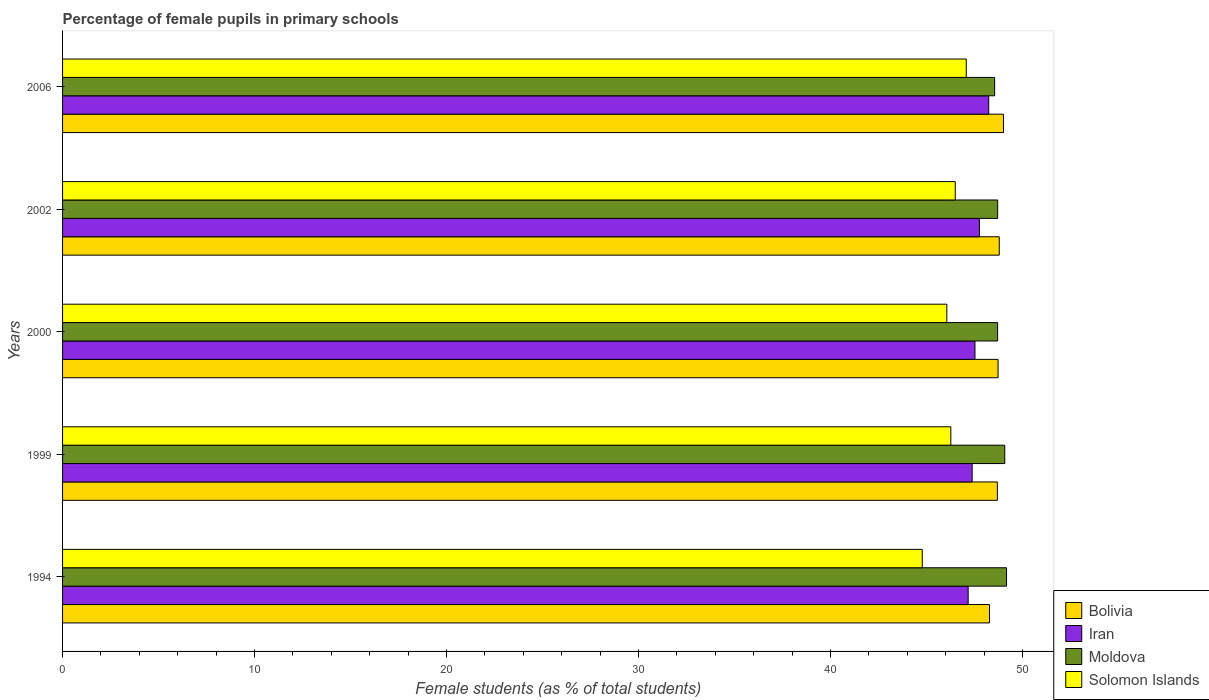How many different coloured bars are there?
Offer a terse response. 4. How many groups of bars are there?
Your answer should be very brief. 5. Are the number of bars per tick equal to the number of legend labels?
Your answer should be compact. Yes. Are the number of bars on each tick of the Y-axis equal?
Offer a very short reply. Yes. In how many cases, is the number of bars for a given year not equal to the number of legend labels?
Make the answer very short. 0. What is the percentage of female pupils in primary schools in Iran in 2002?
Keep it short and to the point. 47.76. Across all years, what is the maximum percentage of female pupils in primary schools in Iran?
Provide a short and direct response. 48.24. Across all years, what is the minimum percentage of female pupils in primary schools in Solomon Islands?
Your response must be concise. 44.78. In which year was the percentage of female pupils in primary schools in Solomon Islands minimum?
Provide a short and direct response. 1994. What is the total percentage of female pupils in primary schools in Bolivia in the graph?
Offer a terse response. 243.51. What is the difference between the percentage of female pupils in primary schools in Moldova in 1999 and that in 2006?
Provide a succinct answer. 0.53. What is the difference between the percentage of female pupils in primary schools in Moldova in 2006 and the percentage of female pupils in primary schools in Solomon Islands in 2000?
Your answer should be compact. 2.49. What is the average percentage of female pupils in primary schools in Iran per year?
Provide a short and direct response. 47.62. In the year 2000, what is the difference between the percentage of female pupils in primary schools in Iran and percentage of female pupils in primary schools in Moldova?
Your answer should be compact. -1.18. What is the ratio of the percentage of female pupils in primary schools in Bolivia in 1999 to that in 2000?
Provide a short and direct response. 1. Is the percentage of female pupils in primary schools in Iran in 1994 less than that in 2002?
Provide a short and direct response. Yes. What is the difference between the highest and the second highest percentage of female pupils in primary schools in Bolivia?
Give a very brief answer. 0.22. What is the difference between the highest and the lowest percentage of female pupils in primary schools in Bolivia?
Keep it short and to the point. 0.73. Is it the case that in every year, the sum of the percentage of female pupils in primary schools in Solomon Islands and percentage of female pupils in primary schools in Bolivia is greater than the sum of percentage of female pupils in primary schools in Moldova and percentage of female pupils in primary schools in Iran?
Provide a short and direct response. No. What does the 2nd bar from the top in 1994 represents?
Make the answer very short. Moldova. What does the 4th bar from the bottom in 2006 represents?
Keep it short and to the point. Solomon Islands. Is it the case that in every year, the sum of the percentage of female pupils in primary schools in Iran and percentage of female pupils in primary schools in Solomon Islands is greater than the percentage of female pupils in primary schools in Moldova?
Your response must be concise. Yes. How many bars are there?
Your answer should be compact. 20. How many years are there in the graph?
Offer a terse response. 5. Does the graph contain any zero values?
Make the answer very short. No. How many legend labels are there?
Provide a succinct answer. 4. How are the legend labels stacked?
Your answer should be very brief. Vertical. What is the title of the graph?
Make the answer very short. Percentage of female pupils in primary schools. What is the label or title of the X-axis?
Offer a terse response. Female students (as % of total students). What is the Female students (as % of total students) of Bolivia in 1994?
Give a very brief answer. 48.28. What is the Female students (as % of total students) in Iran in 1994?
Make the answer very short. 47.17. What is the Female students (as % of total students) of Moldova in 1994?
Provide a short and direct response. 49.17. What is the Female students (as % of total students) of Solomon Islands in 1994?
Your answer should be very brief. 44.78. What is the Female students (as % of total students) of Bolivia in 1999?
Offer a terse response. 48.69. What is the Female students (as % of total students) of Iran in 1999?
Your answer should be very brief. 47.38. What is the Female students (as % of total students) of Moldova in 1999?
Offer a terse response. 49.08. What is the Female students (as % of total students) of Solomon Islands in 1999?
Your answer should be very brief. 46.27. What is the Female students (as % of total students) of Bolivia in 2000?
Your answer should be compact. 48.73. What is the Female students (as % of total students) in Iran in 2000?
Ensure brevity in your answer.  47.53. What is the Female students (as % of total students) in Moldova in 2000?
Give a very brief answer. 48.71. What is the Female students (as % of total students) in Solomon Islands in 2000?
Your response must be concise. 46.06. What is the Female students (as % of total students) of Bolivia in 2002?
Ensure brevity in your answer.  48.79. What is the Female students (as % of total students) of Iran in 2002?
Your response must be concise. 47.76. What is the Female students (as % of total students) in Moldova in 2002?
Provide a short and direct response. 48.71. What is the Female students (as % of total students) in Solomon Islands in 2002?
Give a very brief answer. 46.5. What is the Female students (as % of total students) in Bolivia in 2006?
Provide a short and direct response. 49.01. What is the Female students (as % of total students) in Iran in 2006?
Make the answer very short. 48.24. What is the Female students (as % of total students) of Moldova in 2006?
Your answer should be compact. 48.55. What is the Female students (as % of total students) of Solomon Islands in 2006?
Provide a short and direct response. 47.07. Across all years, what is the maximum Female students (as % of total students) of Bolivia?
Make the answer very short. 49.01. Across all years, what is the maximum Female students (as % of total students) of Iran?
Provide a succinct answer. 48.24. Across all years, what is the maximum Female students (as % of total students) in Moldova?
Offer a terse response. 49.17. Across all years, what is the maximum Female students (as % of total students) in Solomon Islands?
Ensure brevity in your answer.  47.07. Across all years, what is the minimum Female students (as % of total students) in Bolivia?
Make the answer very short. 48.28. Across all years, what is the minimum Female students (as % of total students) in Iran?
Make the answer very short. 47.17. Across all years, what is the minimum Female students (as % of total students) in Moldova?
Offer a terse response. 48.55. Across all years, what is the minimum Female students (as % of total students) in Solomon Islands?
Your answer should be very brief. 44.78. What is the total Female students (as % of total students) of Bolivia in the graph?
Your answer should be very brief. 243.51. What is the total Female students (as % of total students) of Iran in the graph?
Provide a short and direct response. 238.08. What is the total Female students (as % of total students) of Moldova in the graph?
Ensure brevity in your answer.  244.22. What is the total Female students (as % of total students) of Solomon Islands in the graph?
Provide a short and direct response. 230.68. What is the difference between the Female students (as % of total students) of Bolivia in 1994 and that in 1999?
Ensure brevity in your answer.  -0.41. What is the difference between the Female students (as % of total students) of Iran in 1994 and that in 1999?
Give a very brief answer. -0.21. What is the difference between the Female students (as % of total students) in Moldova in 1994 and that in 1999?
Give a very brief answer. 0.09. What is the difference between the Female students (as % of total students) of Solomon Islands in 1994 and that in 1999?
Keep it short and to the point. -1.49. What is the difference between the Female students (as % of total students) of Bolivia in 1994 and that in 2000?
Offer a very short reply. -0.45. What is the difference between the Female students (as % of total students) of Iran in 1994 and that in 2000?
Make the answer very short. -0.36. What is the difference between the Female students (as % of total students) of Moldova in 1994 and that in 2000?
Give a very brief answer. 0.46. What is the difference between the Female students (as % of total students) in Solomon Islands in 1994 and that in 2000?
Provide a short and direct response. -1.28. What is the difference between the Female students (as % of total students) in Bolivia in 1994 and that in 2002?
Keep it short and to the point. -0.51. What is the difference between the Female students (as % of total students) in Iran in 1994 and that in 2002?
Your answer should be very brief. -0.59. What is the difference between the Female students (as % of total students) in Moldova in 1994 and that in 2002?
Give a very brief answer. 0.46. What is the difference between the Female students (as % of total students) in Solomon Islands in 1994 and that in 2002?
Make the answer very short. -1.72. What is the difference between the Female students (as % of total students) of Bolivia in 1994 and that in 2006?
Provide a short and direct response. -0.73. What is the difference between the Female students (as % of total students) in Iran in 1994 and that in 2006?
Your answer should be compact. -1.07. What is the difference between the Female students (as % of total students) of Moldova in 1994 and that in 2006?
Ensure brevity in your answer.  0.62. What is the difference between the Female students (as % of total students) in Solomon Islands in 1994 and that in 2006?
Provide a short and direct response. -2.29. What is the difference between the Female students (as % of total students) in Bolivia in 1999 and that in 2000?
Your answer should be compact. -0.04. What is the difference between the Female students (as % of total students) in Iran in 1999 and that in 2000?
Provide a succinct answer. -0.15. What is the difference between the Female students (as % of total students) in Moldova in 1999 and that in 2000?
Your answer should be compact. 0.37. What is the difference between the Female students (as % of total students) of Solomon Islands in 1999 and that in 2000?
Provide a short and direct response. 0.21. What is the difference between the Female students (as % of total students) in Bolivia in 1999 and that in 2002?
Keep it short and to the point. -0.1. What is the difference between the Female students (as % of total students) of Iran in 1999 and that in 2002?
Ensure brevity in your answer.  -0.38. What is the difference between the Female students (as % of total students) in Moldova in 1999 and that in 2002?
Your answer should be very brief. 0.37. What is the difference between the Female students (as % of total students) in Solomon Islands in 1999 and that in 2002?
Keep it short and to the point. -0.23. What is the difference between the Female students (as % of total students) of Bolivia in 1999 and that in 2006?
Your answer should be very brief. -0.32. What is the difference between the Female students (as % of total students) of Iran in 1999 and that in 2006?
Your answer should be very brief. -0.86. What is the difference between the Female students (as % of total students) in Moldova in 1999 and that in 2006?
Your response must be concise. 0.53. What is the difference between the Female students (as % of total students) in Solomon Islands in 1999 and that in 2006?
Provide a short and direct response. -0.8. What is the difference between the Female students (as % of total students) in Bolivia in 2000 and that in 2002?
Keep it short and to the point. -0.06. What is the difference between the Female students (as % of total students) of Iran in 2000 and that in 2002?
Provide a succinct answer. -0.23. What is the difference between the Female students (as % of total students) in Moldova in 2000 and that in 2002?
Give a very brief answer. -0. What is the difference between the Female students (as % of total students) in Solomon Islands in 2000 and that in 2002?
Your answer should be compact. -0.44. What is the difference between the Female students (as % of total students) of Bolivia in 2000 and that in 2006?
Provide a short and direct response. -0.28. What is the difference between the Female students (as % of total students) in Iran in 2000 and that in 2006?
Give a very brief answer. -0.72. What is the difference between the Female students (as % of total students) of Moldova in 2000 and that in 2006?
Offer a very short reply. 0.15. What is the difference between the Female students (as % of total students) of Solomon Islands in 2000 and that in 2006?
Keep it short and to the point. -1.01. What is the difference between the Female students (as % of total students) in Bolivia in 2002 and that in 2006?
Provide a succinct answer. -0.22. What is the difference between the Female students (as % of total students) of Iran in 2002 and that in 2006?
Give a very brief answer. -0.48. What is the difference between the Female students (as % of total students) in Moldova in 2002 and that in 2006?
Make the answer very short. 0.16. What is the difference between the Female students (as % of total students) of Solomon Islands in 2002 and that in 2006?
Offer a terse response. -0.57. What is the difference between the Female students (as % of total students) in Bolivia in 1994 and the Female students (as % of total students) in Iran in 1999?
Provide a short and direct response. 0.9. What is the difference between the Female students (as % of total students) of Bolivia in 1994 and the Female students (as % of total students) of Moldova in 1999?
Offer a terse response. -0.79. What is the difference between the Female students (as % of total students) of Bolivia in 1994 and the Female students (as % of total students) of Solomon Islands in 1999?
Offer a terse response. 2.01. What is the difference between the Female students (as % of total students) in Iran in 1994 and the Female students (as % of total students) in Moldova in 1999?
Your response must be concise. -1.91. What is the difference between the Female students (as % of total students) of Iran in 1994 and the Female students (as % of total students) of Solomon Islands in 1999?
Offer a very short reply. 0.9. What is the difference between the Female students (as % of total students) in Moldova in 1994 and the Female students (as % of total students) in Solomon Islands in 1999?
Keep it short and to the point. 2.9. What is the difference between the Female students (as % of total students) in Bolivia in 1994 and the Female students (as % of total students) in Iran in 2000?
Ensure brevity in your answer.  0.76. What is the difference between the Female students (as % of total students) of Bolivia in 1994 and the Female students (as % of total students) of Moldova in 2000?
Offer a very short reply. -0.42. What is the difference between the Female students (as % of total students) in Bolivia in 1994 and the Female students (as % of total students) in Solomon Islands in 2000?
Your response must be concise. 2.22. What is the difference between the Female students (as % of total students) in Iran in 1994 and the Female students (as % of total students) in Moldova in 2000?
Offer a terse response. -1.54. What is the difference between the Female students (as % of total students) of Iran in 1994 and the Female students (as % of total students) of Solomon Islands in 2000?
Your answer should be very brief. 1.11. What is the difference between the Female students (as % of total students) in Moldova in 1994 and the Female students (as % of total students) in Solomon Islands in 2000?
Give a very brief answer. 3.11. What is the difference between the Female students (as % of total students) in Bolivia in 1994 and the Female students (as % of total students) in Iran in 2002?
Ensure brevity in your answer.  0.53. What is the difference between the Female students (as % of total students) in Bolivia in 1994 and the Female students (as % of total students) in Moldova in 2002?
Ensure brevity in your answer.  -0.43. What is the difference between the Female students (as % of total students) of Bolivia in 1994 and the Female students (as % of total students) of Solomon Islands in 2002?
Keep it short and to the point. 1.78. What is the difference between the Female students (as % of total students) of Iran in 1994 and the Female students (as % of total students) of Moldova in 2002?
Provide a short and direct response. -1.54. What is the difference between the Female students (as % of total students) of Iran in 1994 and the Female students (as % of total students) of Solomon Islands in 2002?
Give a very brief answer. 0.67. What is the difference between the Female students (as % of total students) in Moldova in 1994 and the Female students (as % of total students) in Solomon Islands in 2002?
Provide a succinct answer. 2.67. What is the difference between the Female students (as % of total students) of Bolivia in 1994 and the Female students (as % of total students) of Iran in 2006?
Your response must be concise. 0.04. What is the difference between the Female students (as % of total students) in Bolivia in 1994 and the Female students (as % of total students) in Moldova in 2006?
Keep it short and to the point. -0.27. What is the difference between the Female students (as % of total students) in Bolivia in 1994 and the Female students (as % of total students) in Solomon Islands in 2006?
Ensure brevity in your answer.  1.21. What is the difference between the Female students (as % of total students) in Iran in 1994 and the Female students (as % of total students) in Moldova in 2006?
Make the answer very short. -1.38. What is the difference between the Female students (as % of total students) in Iran in 1994 and the Female students (as % of total students) in Solomon Islands in 2006?
Give a very brief answer. 0.1. What is the difference between the Female students (as % of total students) in Moldova in 1994 and the Female students (as % of total students) in Solomon Islands in 2006?
Provide a short and direct response. 2.1. What is the difference between the Female students (as % of total students) in Bolivia in 1999 and the Female students (as % of total students) in Iran in 2000?
Keep it short and to the point. 1.17. What is the difference between the Female students (as % of total students) of Bolivia in 1999 and the Female students (as % of total students) of Moldova in 2000?
Provide a short and direct response. -0.01. What is the difference between the Female students (as % of total students) of Bolivia in 1999 and the Female students (as % of total students) of Solomon Islands in 2000?
Your answer should be very brief. 2.63. What is the difference between the Female students (as % of total students) in Iran in 1999 and the Female students (as % of total students) in Moldova in 2000?
Offer a very short reply. -1.33. What is the difference between the Female students (as % of total students) in Iran in 1999 and the Female students (as % of total students) in Solomon Islands in 2000?
Ensure brevity in your answer.  1.32. What is the difference between the Female students (as % of total students) of Moldova in 1999 and the Female students (as % of total students) of Solomon Islands in 2000?
Your answer should be very brief. 3.02. What is the difference between the Female students (as % of total students) of Bolivia in 1999 and the Female students (as % of total students) of Iran in 2002?
Offer a very short reply. 0.94. What is the difference between the Female students (as % of total students) of Bolivia in 1999 and the Female students (as % of total students) of Moldova in 2002?
Your answer should be very brief. -0.02. What is the difference between the Female students (as % of total students) of Bolivia in 1999 and the Female students (as % of total students) of Solomon Islands in 2002?
Your answer should be compact. 2.19. What is the difference between the Female students (as % of total students) of Iran in 1999 and the Female students (as % of total students) of Moldova in 2002?
Give a very brief answer. -1.33. What is the difference between the Female students (as % of total students) of Iran in 1999 and the Female students (as % of total students) of Solomon Islands in 2002?
Your answer should be very brief. 0.88. What is the difference between the Female students (as % of total students) in Moldova in 1999 and the Female students (as % of total students) in Solomon Islands in 2002?
Make the answer very short. 2.58. What is the difference between the Female students (as % of total students) in Bolivia in 1999 and the Female students (as % of total students) in Iran in 2006?
Your response must be concise. 0.45. What is the difference between the Female students (as % of total students) of Bolivia in 1999 and the Female students (as % of total students) of Moldova in 2006?
Offer a terse response. 0.14. What is the difference between the Female students (as % of total students) in Bolivia in 1999 and the Female students (as % of total students) in Solomon Islands in 2006?
Your answer should be very brief. 1.62. What is the difference between the Female students (as % of total students) in Iran in 1999 and the Female students (as % of total students) in Moldova in 2006?
Provide a succinct answer. -1.17. What is the difference between the Female students (as % of total students) in Iran in 1999 and the Female students (as % of total students) in Solomon Islands in 2006?
Provide a succinct answer. 0.31. What is the difference between the Female students (as % of total students) in Moldova in 1999 and the Female students (as % of total students) in Solomon Islands in 2006?
Ensure brevity in your answer.  2. What is the difference between the Female students (as % of total students) in Bolivia in 2000 and the Female students (as % of total students) in Moldova in 2002?
Give a very brief answer. 0.02. What is the difference between the Female students (as % of total students) in Bolivia in 2000 and the Female students (as % of total students) in Solomon Islands in 2002?
Give a very brief answer. 2.23. What is the difference between the Female students (as % of total students) of Iran in 2000 and the Female students (as % of total students) of Moldova in 2002?
Offer a terse response. -1.18. What is the difference between the Female students (as % of total students) of Iran in 2000 and the Female students (as % of total students) of Solomon Islands in 2002?
Ensure brevity in your answer.  1.03. What is the difference between the Female students (as % of total students) of Moldova in 2000 and the Female students (as % of total students) of Solomon Islands in 2002?
Provide a succinct answer. 2.21. What is the difference between the Female students (as % of total students) of Bolivia in 2000 and the Female students (as % of total students) of Iran in 2006?
Offer a very short reply. 0.49. What is the difference between the Female students (as % of total students) in Bolivia in 2000 and the Female students (as % of total students) in Moldova in 2006?
Make the answer very short. 0.18. What is the difference between the Female students (as % of total students) of Bolivia in 2000 and the Female students (as % of total students) of Solomon Islands in 2006?
Offer a terse response. 1.66. What is the difference between the Female students (as % of total students) of Iran in 2000 and the Female students (as % of total students) of Moldova in 2006?
Offer a very short reply. -1.03. What is the difference between the Female students (as % of total students) of Iran in 2000 and the Female students (as % of total students) of Solomon Islands in 2006?
Offer a terse response. 0.45. What is the difference between the Female students (as % of total students) in Moldova in 2000 and the Female students (as % of total students) in Solomon Islands in 2006?
Your response must be concise. 1.63. What is the difference between the Female students (as % of total students) in Bolivia in 2002 and the Female students (as % of total students) in Iran in 2006?
Your answer should be very brief. 0.55. What is the difference between the Female students (as % of total students) in Bolivia in 2002 and the Female students (as % of total students) in Moldova in 2006?
Keep it short and to the point. 0.24. What is the difference between the Female students (as % of total students) of Bolivia in 2002 and the Female students (as % of total students) of Solomon Islands in 2006?
Your answer should be very brief. 1.72. What is the difference between the Female students (as % of total students) of Iran in 2002 and the Female students (as % of total students) of Moldova in 2006?
Make the answer very short. -0.79. What is the difference between the Female students (as % of total students) of Iran in 2002 and the Female students (as % of total students) of Solomon Islands in 2006?
Provide a succinct answer. 0.68. What is the difference between the Female students (as % of total students) of Moldova in 2002 and the Female students (as % of total students) of Solomon Islands in 2006?
Ensure brevity in your answer.  1.64. What is the average Female students (as % of total students) of Bolivia per year?
Your response must be concise. 48.7. What is the average Female students (as % of total students) of Iran per year?
Your answer should be very brief. 47.62. What is the average Female students (as % of total students) of Moldova per year?
Your answer should be very brief. 48.84. What is the average Female students (as % of total students) of Solomon Islands per year?
Provide a succinct answer. 46.14. In the year 1994, what is the difference between the Female students (as % of total students) in Bolivia and Female students (as % of total students) in Iran?
Offer a very short reply. 1.11. In the year 1994, what is the difference between the Female students (as % of total students) of Bolivia and Female students (as % of total students) of Moldova?
Your answer should be very brief. -0.89. In the year 1994, what is the difference between the Female students (as % of total students) in Bolivia and Female students (as % of total students) in Solomon Islands?
Make the answer very short. 3.5. In the year 1994, what is the difference between the Female students (as % of total students) of Iran and Female students (as % of total students) of Moldova?
Provide a short and direct response. -2. In the year 1994, what is the difference between the Female students (as % of total students) in Iran and Female students (as % of total students) in Solomon Islands?
Your answer should be very brief. 2.39. In the year 1994, what is the difference between the Female students (as % of total students) in Moldova and Female students (as % of total students) in Solomon Islands?
Ensure brevity in your answer.  4.39. In the year 1999, what is the difference between the Female students (as % of total students) in Bolivia and Female students (as % of total students) in Iran?
Your response must be concise. 1.31. In the year 1999, what is the difference between the Female students (as % of total students) in Bolivia and Female students (as % of total students) in Moldova?
Make the answer very short. -0.38. In the year 1999, what is the difference between the Female students (as % of total students) of Bolivia and Female students (as % of total students) of Solomon Islands?
Offer a very short reply. 2.43. In the year 1999, what is the difference between the Female students (as % of total students) of Iran and Female students (as % of total students) of Moldova?
Provide a succinct answer. -1.7. In the year 1999, what is the difference between the Female students (as % of total students) of Iran and Female students (as % of total students) of Solomon Islands?
Your answer should be compact. 1.11. In the year 1999, what is the difference between the Female students (as % of total students) of Moldova and Female students (as % of total students) of Solomon Islands?
Your response must be concise. 2.81. In the year 2000, what is the difference between the Female students (as % of total students) in Bolivia and Female students (as % of total students) in Iran?
Your response must be concise. 1.2. In the year 2000, what is the difference between the Female students (as % of total students) of Bolivia and Female students (as % of total students) of Moldova?
Keep it short and to the point. 0.02. In the year 2000, what is the difference between the Female students (as % of total students) in Bolivia and Female students (as % of total students) in Solomon Islands?
Give a very brief answer. 2.67. In the year 2000, what is the difference between the Female students (as % of total students) of Iran and Female students (as % of total students) of Moldova?
Give a very brief answer. -1.18. In the year 2000, what is the difference between the Female students (as % of total students) in Iran and Female students (as % of total students) in Solomon Islands?
Your answer should be very brief. 1.47. In the year 2000, what is the difference between the Female students (as % of total students) of Moldova and Female students (as % of total students) of Solomon Islands?
Make the answer very short. 2.65. In the year 2002, what is the difference between the Female students (as % of total students) in Bolivia and Female students (as % of total students) in Iran?
Offer a terse response. 1.03. In the year 2002, what is the difference between the Female students (as % of total students) of Bolivia and Female students (as % of total students) of Moldova?
Offer a terse response. 0.08. In the year 2002, what is the difference between the Female students (as % of total students) in Bolivia and Female students (as % of total students) in Solomon Islands?
Give a very brief answer. 2.29. In the year 2002, what is the difference between the Female students (as % of total students) of Iran and Female students (as % of total students) of Moldova?
Your answer should be very brief. -0.95. In the year 2002, what is the difference between the Female students (as % of total students) in Iran and Female students (as % of total students) in Solomon Islands?
Make the answer very short. 1.26. In the year 2002, what is the difference between the Female students (as % of total students) in Moldova and Female students (as % of total students) in Solomon Islands?
Keep it short and to the point. 2.21. In the year 2006, what is the difference between the Female students (as % of total students) of Bolivia and Female students (as % of total students) of Iran?
Provide a short and direct response. 0.77. In the year 2006, what is the difference between the Female students (as % of total students) in Bolivia and Female students (as % of total students) in Moldova?
Your response must be concise. 0.46. In the year 2006, what is the difference between the Female students (as % of total students) of Bolivia and Female students (as % of total students) of Solomon Islands?
Provide a succinct answer. 1.94. In the year 2006, what is the difference between the Female students (as % of total students) in Iran and Female students (as % of total students) in Moldova?
Provide a short and direct response. -0.31. In the year 2006, what is the difference between the Female students (as % of total students) in Iran and Female students (as % of total students) in Solomon Islands?
Your answer should be compact. 1.17. In the year 2006, what is the difference between the Female students (as % of total students) in Moldova and Female students (as % of total students) in Solomon Islands?
Your answer should be very brief. 1.48. What is the ratio of the Female students (as % of total students) in Bolivia in 1994 to that in 1999?
Your response must be concise. 0.99. What is the ratio of the Female students (as % of total students) of Iran in 1994 to that in 1999?
Give a very brief answer. 1. What is the ratio of the Female students (as % of total students) of Solomon Islands in 1994 to that in 1999?
Offer a terse response. 0.97. What is the ratio of the Female students (as % of total students) of Bolivia in 1994 to that in 2000?
Offer a terse response. 0.99. What is the ratio of the Female students (as % of total students) of Iran in 1994 to that in 2000?
Your response must be concise. 0.99. What is the ratio of the Female students (as % of total students) of Moldova in 1994 to that in 2000?
Give a very brief answer. 1.01. What is the ratio of the Female students (as % of total students) of Solomon Islands in 1994 to that in 2000?
Keep it short and to the point. 0.97. What is the ratio of the Female students (as % of total students) in Bolivia in 1994 to that in 2002?
Make the answer very short. 0.99. What is the ratio of the Female students (as % of total students) of Iran in 1994 to that in 2002?
Ensure brevity in your answer.  0.99. What is the ratio of the Female students (as % of total students) of Moldova in 1994 to that in 2002?
Give a very brief answer. 1.01. What is the ratio of the Female students (as % of total students) in Bolivia in 1994 to that in 2006?
Your answer should be very brief. 0.99. What is the ratio of the Female students (as % of total students) of Iran in 1994 to that in 2006?
Your answer should be very brief. 0.98. What is the ratio of the Female students (as % of total students) in Moldova in 1994 to that in 2006?
Make the answer very short. 1.01. What is the ratio of the Female students (as % of total students) in Solomon Islands in 1994 to that in 2006?
Give a very brief answer. 0.95. What is the ratio of the Female students (as % of total students) of Iran in 1999 to that in 2000?
Provide a succinct answer. 1. What is the ratio of the Female students (as % of total students) of Moldova in 1999 to that in 2000?
Ensure brevity in your answer.  1.01. What is the ratio of the Female students (as % of total students) in Bolivia in 1999 to that in 2002?
Provide a succinct answer. 1. What is the ratio of the Female students (as % of total students) of Moldova in 1999 to that in 2002?
Your answer should be compact. 1.01. What is the ratio of the Female students (as % of total students) of Solomon Islands in 1999 to that in 2002?
Your answer should be compact. 0.99. What is the ratio of the Female students (as % of total students) of Bolivia in 1999 to that in 2006?
Make the answer very short. 0.99. What is the ratio of the Female students (as % of total students) of Iran in 1999 to that in 2006?
Your answer should be compact. 0.98. What is the ratio of the Female students (as % of total students) in Moldova in 1999 to that in 2006?
Offer a very short reply. 1.01. What is the ratio of the Female students (as % of total students) in Solomon Islands in 1999 to that in 2006?
Your answer should be very brief. 0.98. What is the ratio of the Female students (as % of total students) of Iran in 2000 to that in 2002?
Keep it short and to the point. 1. What is the ratio of the Female students (as % of total students) in Bolivia in 2000 to that in 2006?
Provide a succinct answer. 0.99. What is the ratio of the Female students (as % of total students) of Iran in 2000 to that in 2006?
Your answer should be very brief. 0.99. What is the ratio of the Female students (as % of total students) in Solomon Islands in 2000 to that in 2006?
Your answer should be compact. 0.98. What is the ratio of the Female students (as % of total students) of Bolivia in 2002 to that in 2006?
Your response must be concise. 1. What is the ratio of the Female students (as % of total students) in Solomon Islands in 2002 to that in 2006?
Provide a short and direct response. 0.99. What is the difference between the highest and the second highest Female students (as % of total students) in Bolivia?
Your response must be concise. 0.22. What is the difference between the highest and the second highest Female students (as % of total students) in Iran?
Provide a short and direct response. 0.48. What is the difference between the highest and the second highest Female students (as % of total students) of Moldova?
Keep it short and to the point. 0.09. What is the difference between the highest and the second highest Female students (as % of total students) in Solomon Islands?
Your answer should be compact. 0.57. What is the difference between the highest and the lowest Female students (as % of total students) in Bolivia?
Give a very brief answer. 0.73. What is the difference between the highest and the lowest Female students (as % of total students) of Iran?
Your response must be concise. 1.07. What is the difference between the highest and the lowest Female students (as % of total students) of Moldova?
Your response must be concise. 0.62. What is the difference between the highest and the lowest Female students (as % of total students) in Solomon Islands?
Your answer should be compact. 2.29. 